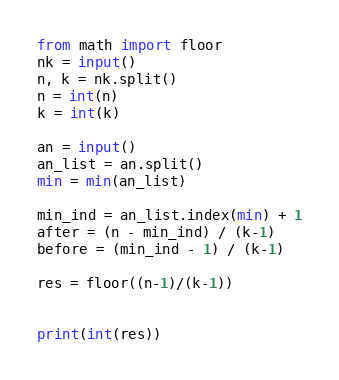Convert code to text. <code><loc_0><loc_0><loc_500><loc_500><_Python_>from math import floor
nk = input()
n, k = nk.split()
n = int(n)
k = int(k)

an = input()
an_list = an.split()
min = min(an_list)

min_ind = an_list.index(min) + 1
after = (n - min_ind) / (k-1)
before = (min_ind - 1) / (k-1)

res = floor((n-1)/(k-1))


print(int(res))
</code> 